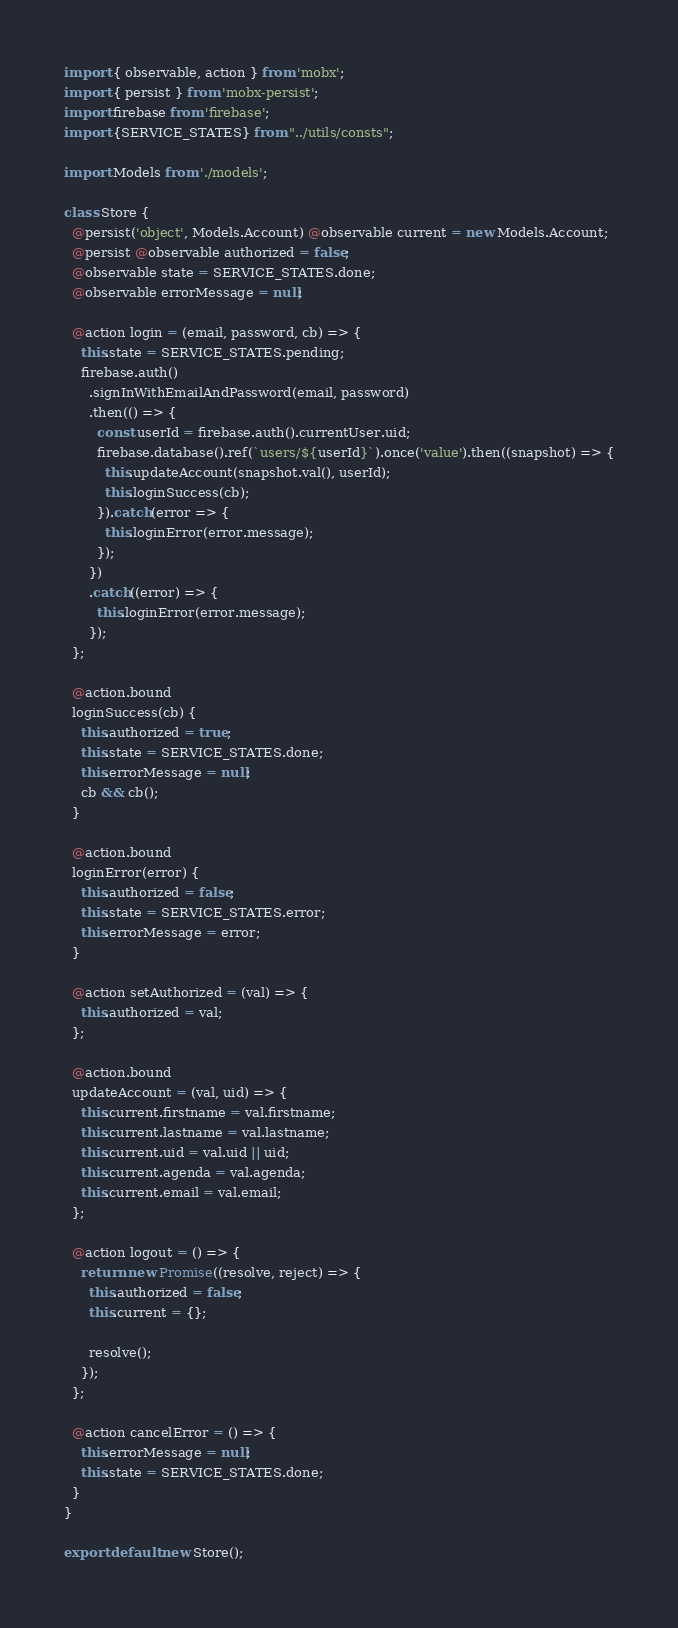Convert code to text. <code><loc_0><loc_0><loc_500><loc_500><_JavaScript_>import { observable, action } from 'mobx';
import { persist } from 'mobx-persist';
import firebase from 'firebase';
import {SERVICE_STATES} from "../utils/consts";

import Models from './models';

class Store {
  @persist('object', Models.Account) @observable current = new Models.Account;
  @persist @observable authorized = false;
  @observable state = SERVICE_STATES.done;
  @observable errorMessage = null;

  @action login = (email, password, cb) => {
    this.state = SERVICE_STATES.pending;
    firebase.auth()
      .signInWithEmailAndPassword(email, password)
      .then(() => {
        const userId = firebase.auth().currentUser.uid;
        firebase.database().ref(`users/${userId}`).once('value').then((snapshot) => {
          this.updateAccount(snapshot.val(), userId);
          this.loginSuccess(cb);
        }).catch(error => {
          this.loginError(error.message);
        });
      })
      .catch((error) => {
        this.loginError(error.message);
      });
  };

  @action.bound
  loginSuccess(cb) {
    this.authorized = true;
    this.state = SERVICE_STATES.done;
    this.errorMessage = null;
    cb && cb();
  }

  @action.bound
  loginError(error) {
    this.authorized = false;
    this.state = SERVICE_STATES.error;
    this.errorMessage = error;
  }

  @action setAuthorized = (val) => {
    this.authorized = val;
  };

  @action.bound
  updateAccount = (val, uid) => {
    this.current.firstname = val.firstname;
    this.current.lastname = val.lastname;
    this.current.uid = val.uid || uid;
    this.current.agenda = val.agenda;
    this.current.email = val.email;
  };

  @action logout = () => {
    return new Promise((resolve, reject) => {
      this.authorized = false;
      this.current = {};

      resolve();
    });
  };

  @action cancelError = () => {
    this.errorMessage = null;
    this.state = SERVICE_STATES.done;
  }
}

export default new Store();</code> 